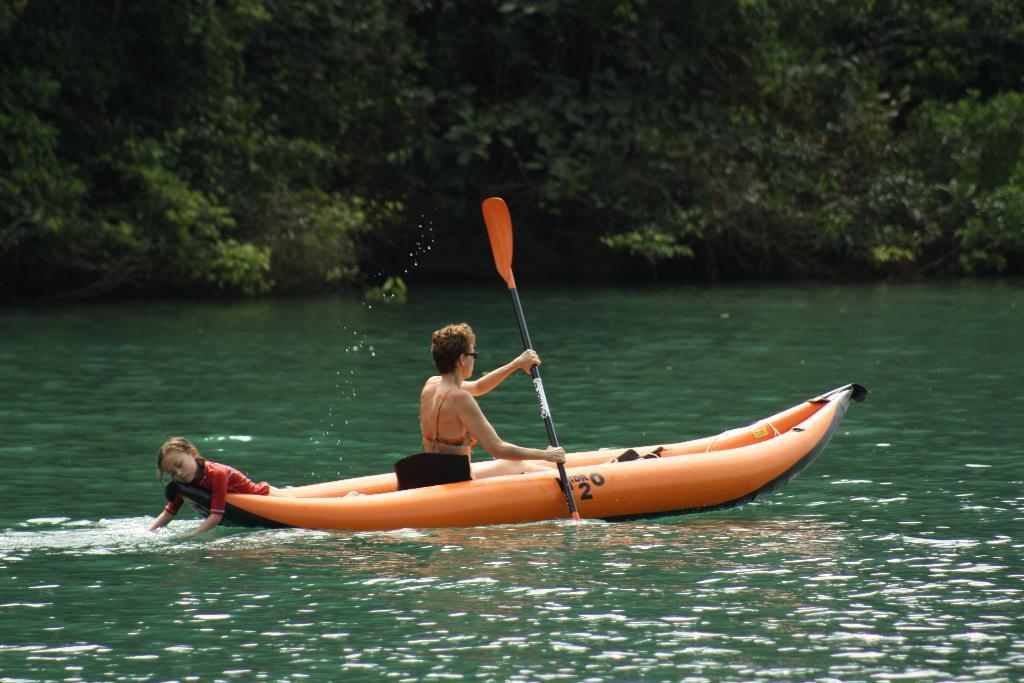In one or two sentences, can you explain what this image depicts? In this image we can see a woman boating on the surface of the water. We can also see the girl. In the background we can see many trees. 